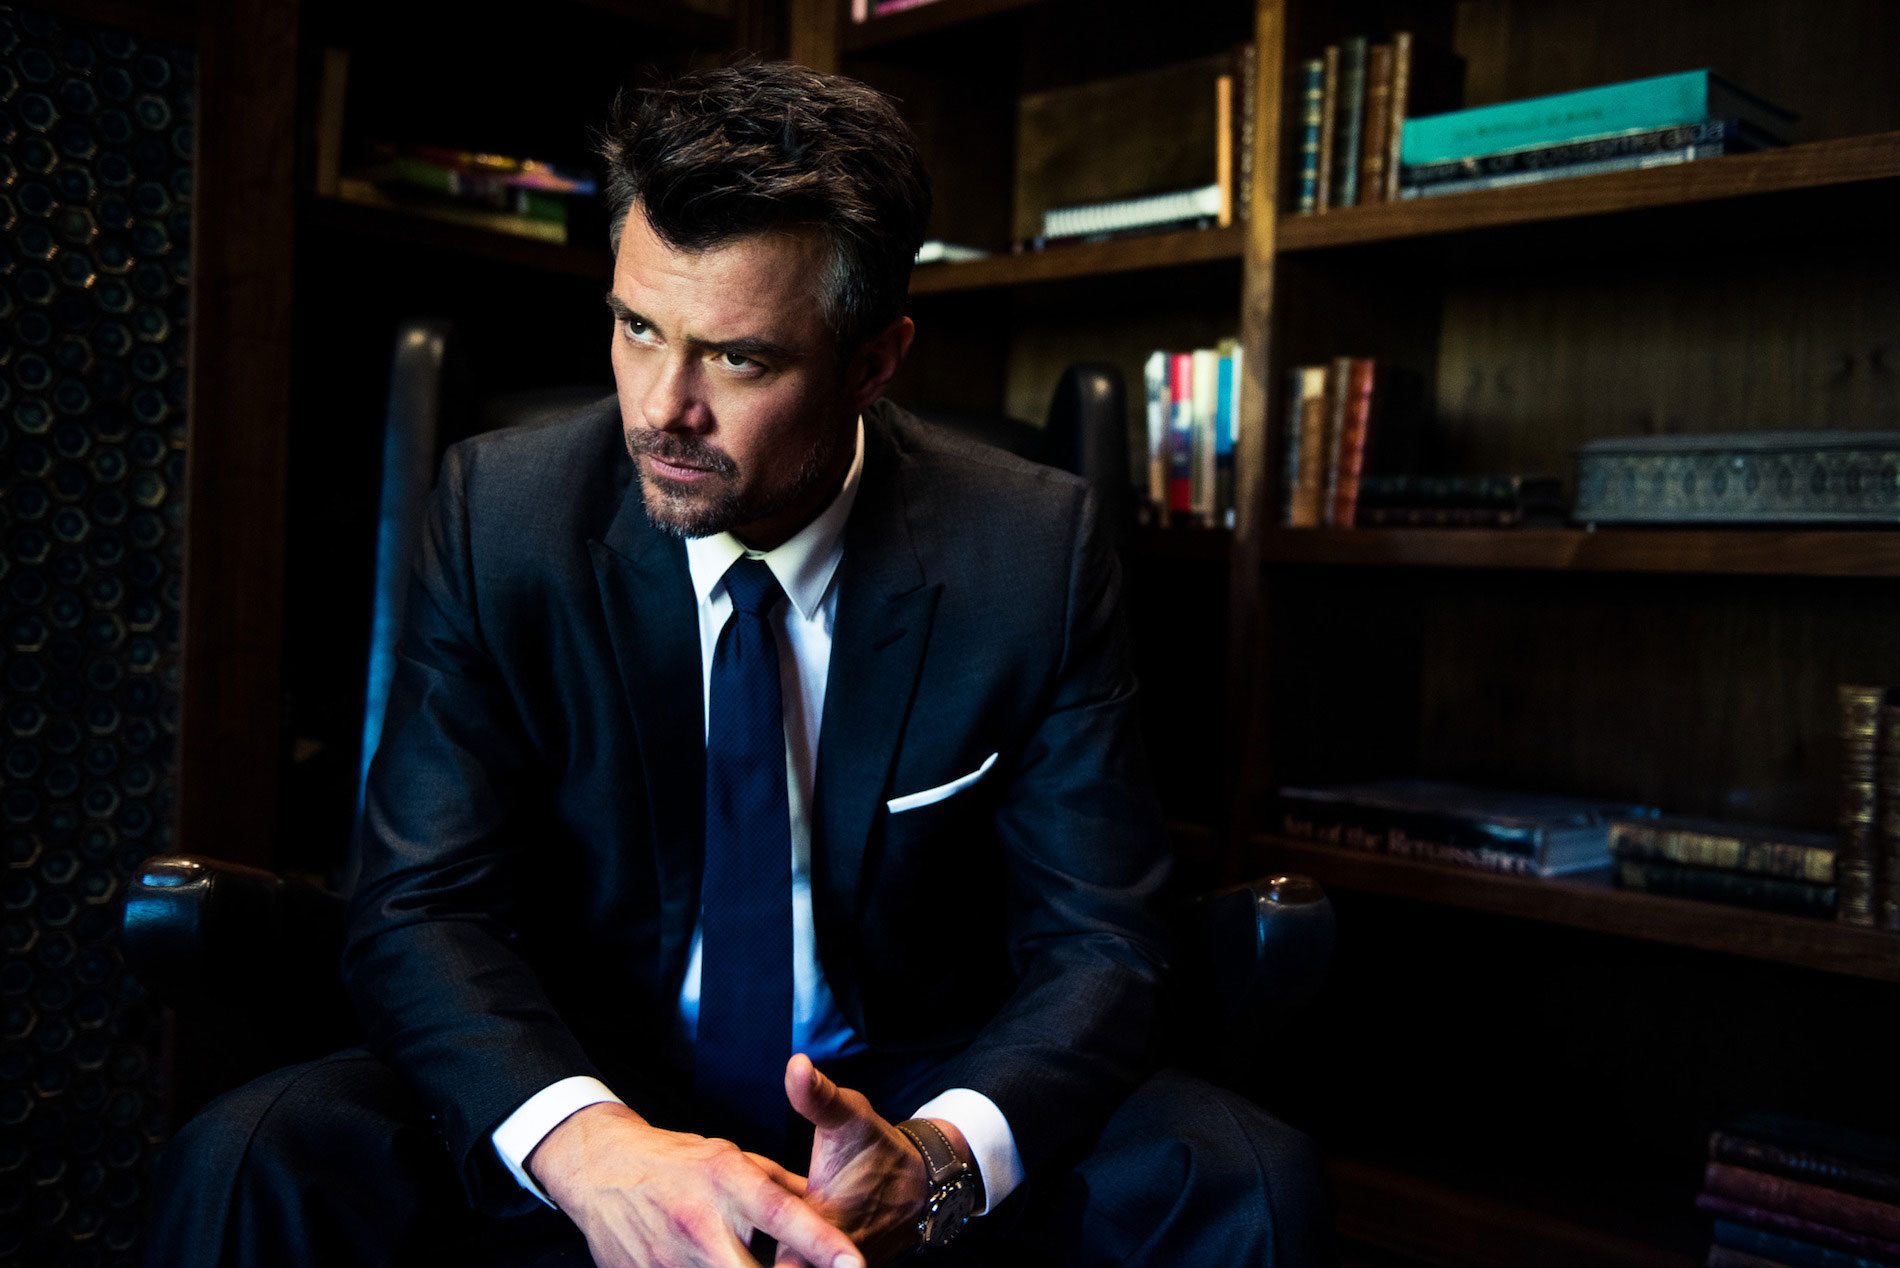Create a short story inspired by the image. In the dim-lit room, Marcus sat in solitude, the weight of unspoken thoughts heavy on his mind. The leather armchair creaked slightly as he shifted, his eyes locked on the dusty bookshelf. Piles of forgotten knowledge stared back at him, each tome a fragment of history, a lesson learned, or a mystery whispered through the ages. He clenched his hands tighter, contemplating the crossroads he faced. Marcus, a high-powered attorney, had built his career by carefully navigating the labyrinth of law and ethics. Yet, tonight, as shadows danced around him, he grappled with the decision that could either save a man's life or expose a deep-seated truth that would unravel everything he believed in. The ambiance of the room mirrored his inner turmoil—a battle between heart and mind. As the hours ticked away, he realized that sometimes, the greatest battles are fought not in courts or boardrooms, but within one's own soul. 